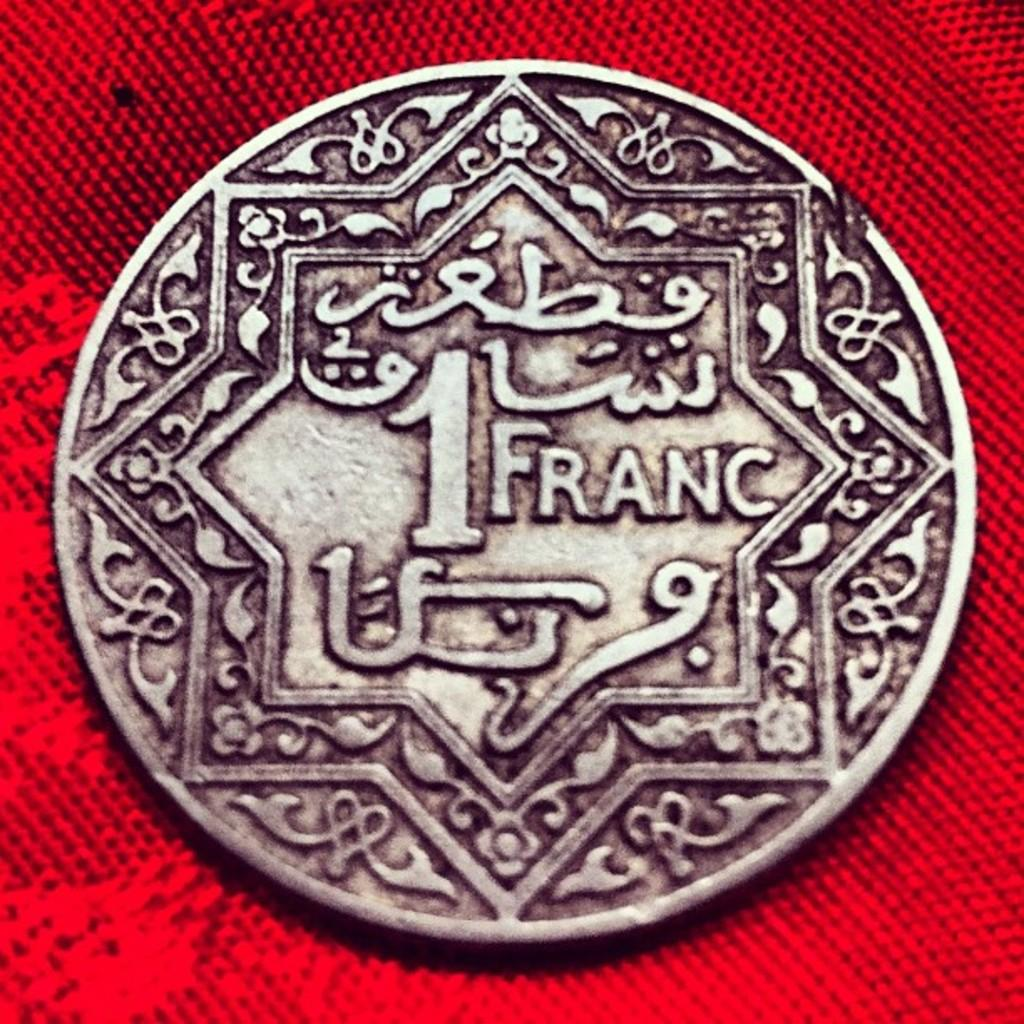<image>
Present a compact description of the photo's key features. A old coin with designs and two stars with the words 1 Franc. 